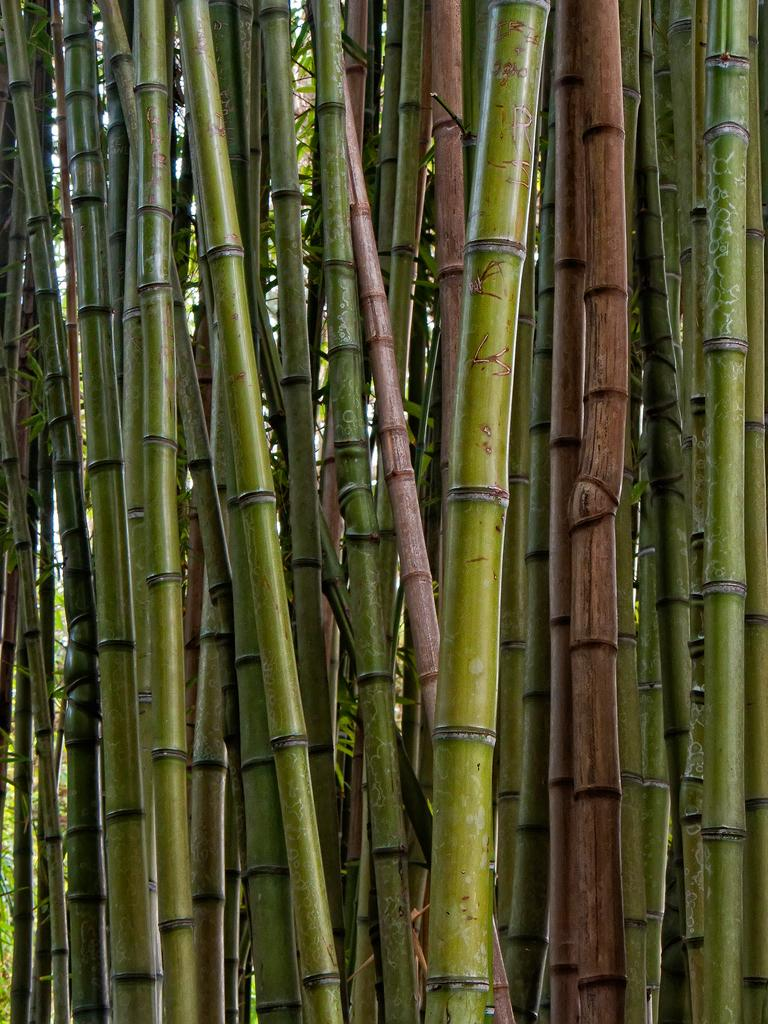What type of sticks are present in the image? There are bamboo sticks in the image. Can you tell me where the mother is located on the map in the image? There is no map or reference to a mother present in the image; it only features bamboo sticks. Is the basketball visible in the image? There is no basketball present in the image; it only features bamboo sticks. 